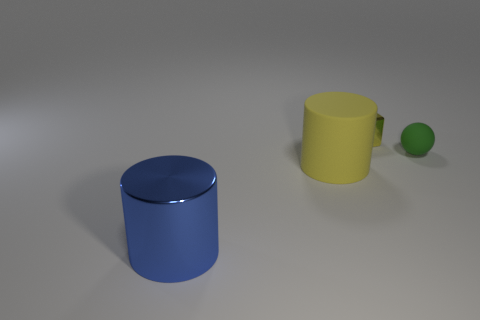Subtract all blue cylinders. How many cylinders are left? 1 Add 3 tiny rubber things. How many objects exist? 7 Subtract 2 cylinders. How many cylinders are left? 0 Subtract all balls. How many objects are left? 3 Subtract all yellow blocks. How many blue cylinders are left? 1 Subtract 0 gray cubes. How many objects are left? 4 Subtract all blue cylinders. Subtract all brown blocks. How many cylinders are left? 1 Subtract all red rubber objects. Subtract all matte spheres. How many objects are left? 3 Add 4 blue metal cylinders. How many blue metal cylinders are left? 5 Add 4 small green matte objects. How many small green matte objects exist? 5 